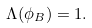Convert formula to latex. <formula><loc_0><loc_0><loc_500><loc_500>\Lambda ( \phi _ { B } ) = 1 .</formula> 